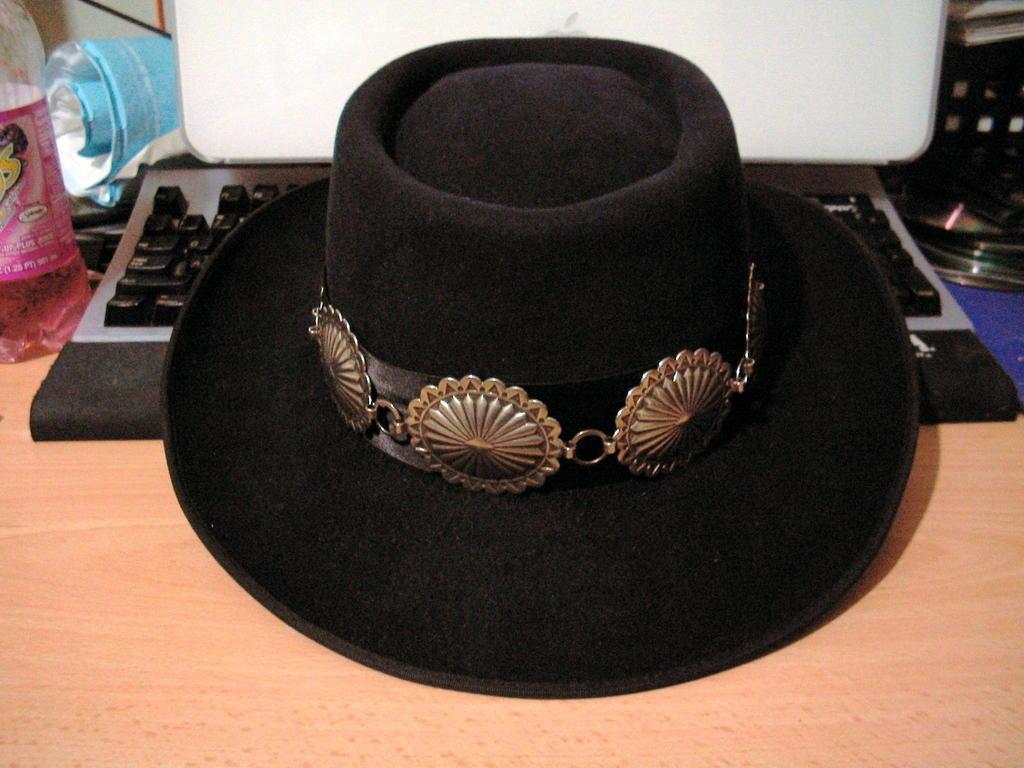How would you summarize this image in a sentence or two? In this image I can see a hat. In the background there is a keyboard. 